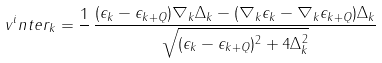Convert formula to latex. <formula><loc_0><loc_0><loc_500><loc_500>v ^ { i } n t e r _ { k } = \frac { 1 } { } \, \frac { ( \epsilon _ { k } - \epsilon _ { k + Q } ) \nabla _ { k } \Delta _ { k } - ( \nabla _ { k } \epsilon _ { k } - \nabla _ { k } \epsilon _ { k + Q } ) \Delta _ { k } } { \sqrt { ( \epsilon _ { k } - \epsilon _ { k + Q } ) ^ { 2 } + 4 \Delta _ { k } ^ { 2 } } }</formula> 